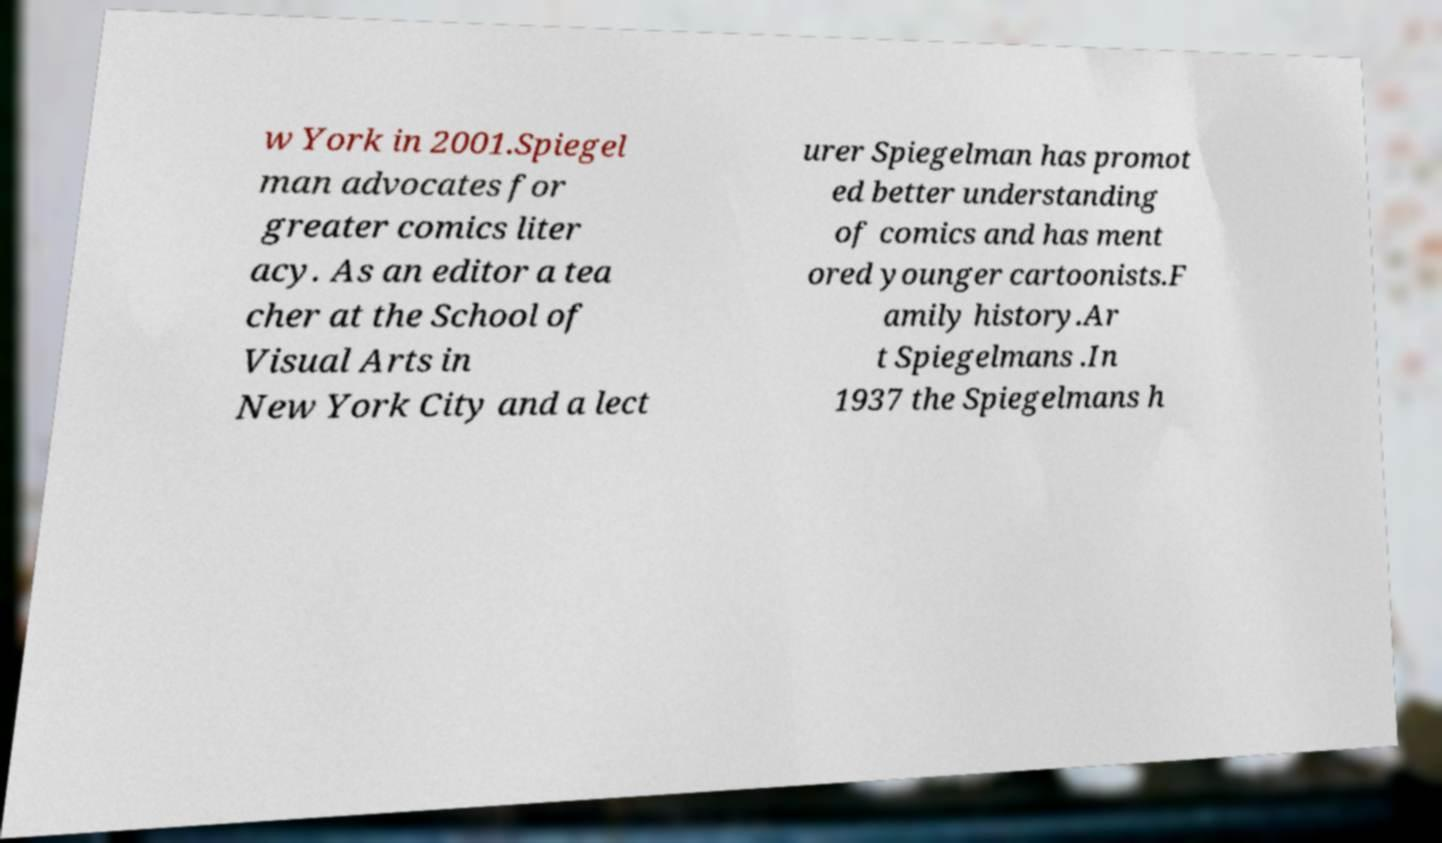There's text embedded in this image that I need extracted. Can you transcribe it verbatim? w York in 2001.Spiegel man advocates for greater comics liter acy. As an editor a tea cher at the School of Visual Arts in New York City and a lect urer Spiegelman has promot ed better understanding of comics and has ment ored younger cartoonists.F amily history.Ar t Spiegelmans .In 1937 the Spiegelmans h 